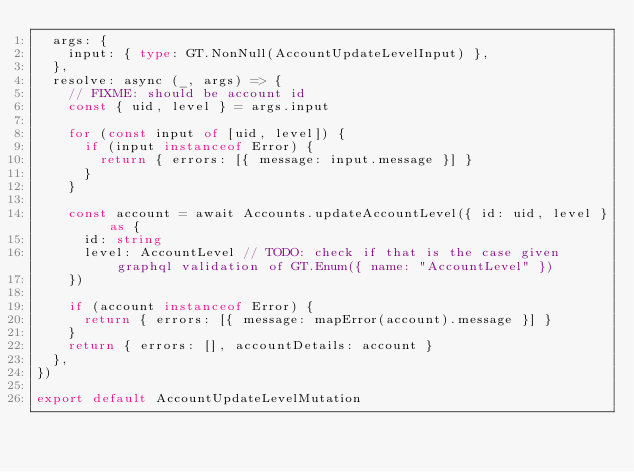Convert code to text. <code><loc_0><loc_0><loc_500><loc_500><_TypeScript_>  args: {
    input: { type: GT.NonNull(AccountUpdateLevelInput) },
  },
  resolve: async (_, args) => {
    // FIXME: should be account id
    const { uid, level } = args.input

    for (const input of [uid, level]) {
      if (input instanceof Error) {
        return { errors: [{ message: input.message }] }
      }
    }

    const account = await Accounts.updateAccountLevel({ id: uid, level } as {
      id: string
      level: AccountLevel // TODO: check if that is the case given graphql validation of GT.Enum({ name: "AccountLevel" })
    })

    if (account instanceof Error) {
      return { errors: [{ message: mapError(account).message }] }
    }
    return { errors: [], accountDetails: account }
  },
})

export default AccountUpdateLevelMutation
</code> 